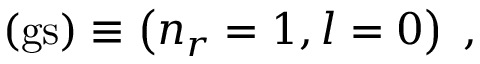Convert formula to latex. <formula><loc_0><loc_0><loc_500><loc_500>( g s ) \equiv \left ( n _ { r } = 1 , l = 0 \right ) \, ,</formula> 